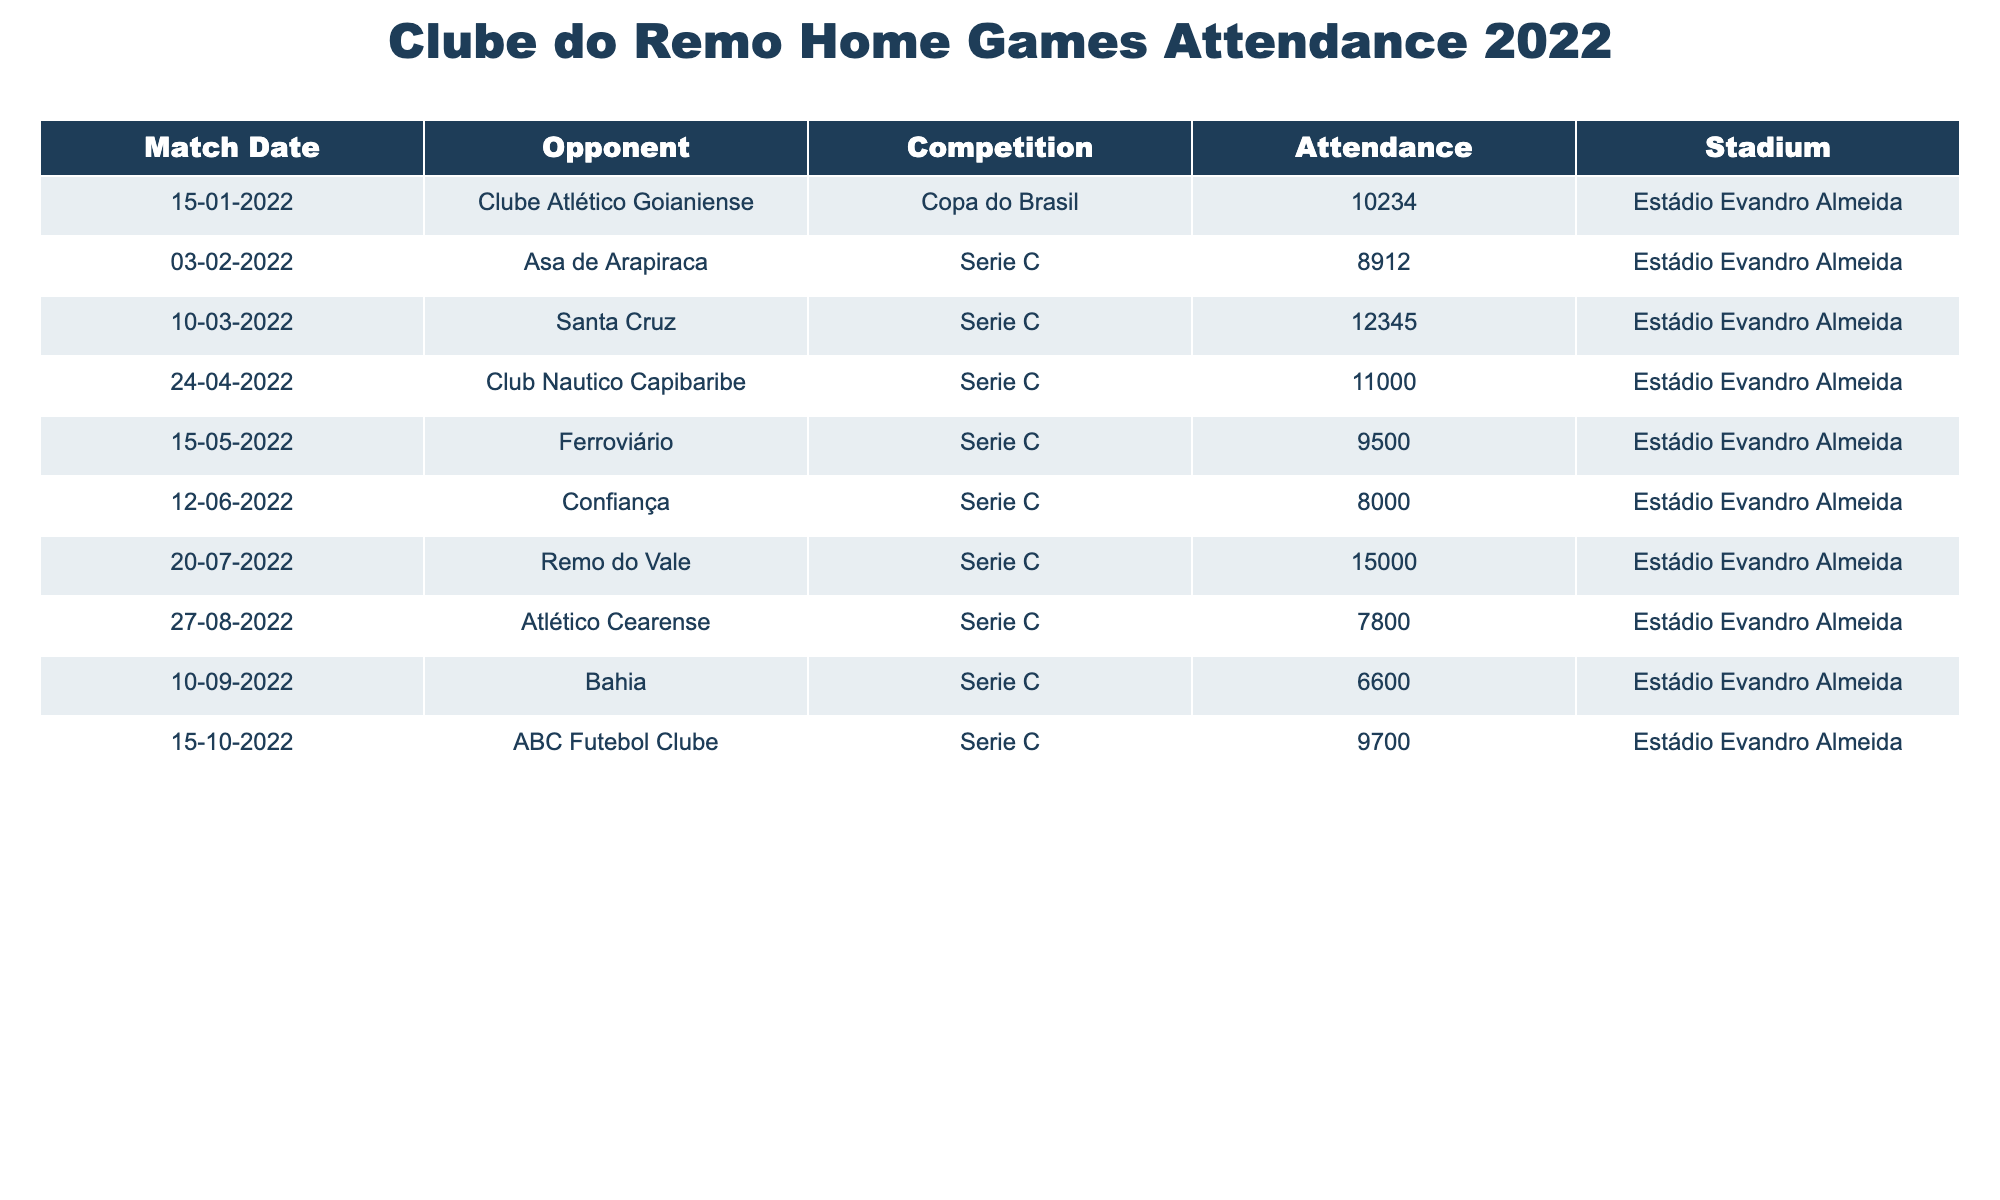What was the highest attendance recorded for a home game? The highest attendance figure listed in the table is 15000 for the match against Remo do Vale on 20th July 2022.
Answer: 15000 Which match had the lowest attendance? The lowest attendance recorded in the table is 6600, which occurred during the match against Bahia on 10th September 2022.
Answer: 6600 How many matches had an attendance of over 10000? By examining the attendance figures, we find that there are three matches with over 10000 attendees: against Santa Cruz (12345), Club Nautico Capibaribe (11000), and Remo do Vale (15000).
Answer: 3 What is the average attendance for Clube do Remo's home games in 2022? To find the average, we sum the attendance figures: 10234 + 8912 + 12345 + 11000 + 9500 + 8000 + 15000 + 7800 + 6600 + 9700 = 102091. There are 10 games, so the average is 102091 / 10 = 10209.1, which rounds to 10209.
Answer: 10209 Did Clube do Remo have more than one game in which attendance was below 8000? There is only one game in which the attendance was below 8000, which is against Confiança (8000). Therefore, the answer is no, they did not have more than one game below this threshold.
Answer: No What was the total attendance for all home games played in Series C? The matches in Series C had attendances of 8912, 12345, 11000, 9500, 8000, 15000, 7800, 6600, and 9700. Adding these figures: 8912 + 12345 + 11000 + 9500 + 8000 + 15000 + 7800 + 6600 + 9700 = 102357.
Answer: 102357 Which opponent drew the largest crowd? The opponent with the largest attendance was Remo do Vale, which attracted 15000 fans to the game on 20th July 2022.
Answer: Remo do Vale Is there a match where the attendance was exactly 9000? Upon reviewing the attendance numbers, there are no matches listed with an attendance figure of exactly 9000. Hence, the answer is no.
Answer: No 